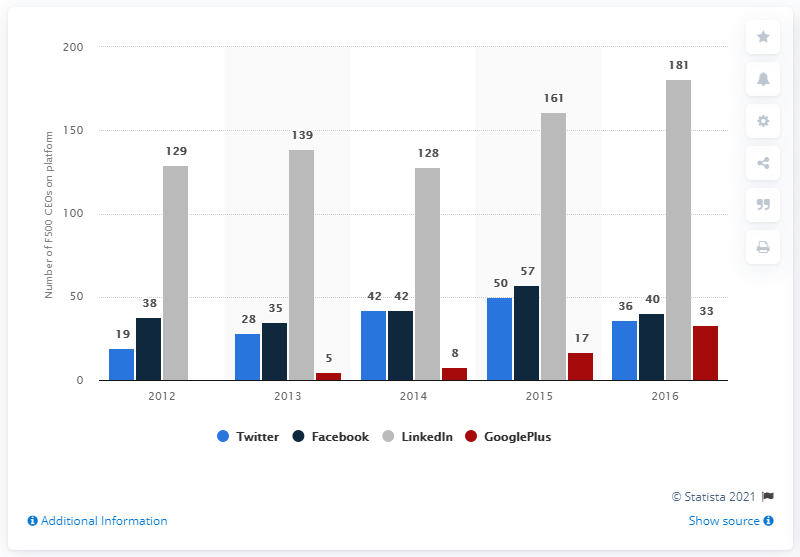Mention a couple of crucial points in this snapshot. During the most recent survey period, 181 Fortune 500 CEOs had a LinkedIn account. LinkedIn is the most popular social network among CEOs. 